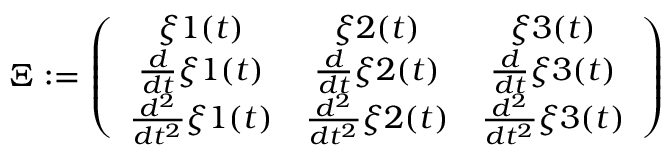Convert formula to latex. <formula><loc_0><loc_0><loc_500><loc_500>\Xi \colon = \left ( \begin{array} { c c c } { \xi { 1 } ( t ) } & { \xi { 2 } ( t ) } & { \xi { 3 } ( t ) } \\ { \frac { d } { d t } \xi { 1 } ( t ) } & { \frac { d } { d t } \xi { 2 } ( t ) } & { \frac { d } { d t } \xi { 3 } ( t ) } \\ { \frac { d ^ { 2 } } { d t ^ { 2 } } \xi { 1 } ( t ) } & { \frac { d ^ { 2 } } { d t ^ { 2 } } \xi { 2 } ( t ) } & { \frac { d ^ { 2 } } { d t ^ { 2 } } \xi { 3 } ( t ) } \end{array} \right )</formula> 